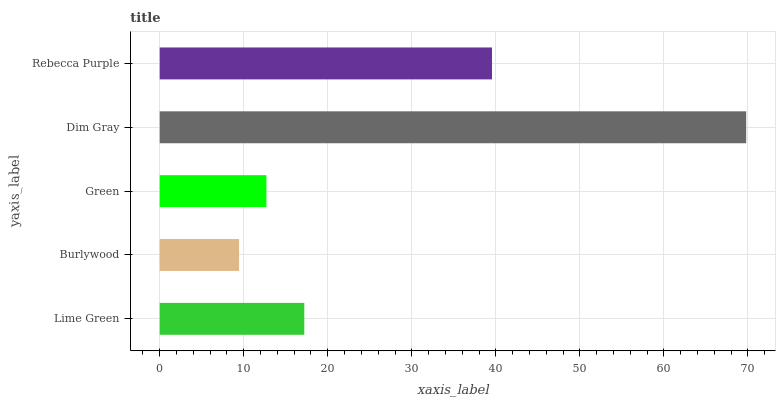Is Burlywood the minimum?
Answer yes or no. Yes. Is Dim Gray the maximum?
Answer yes or no. Yes. Is Green the minimum?
Answer yes or no. No. Is Green the maximum?
Answer yes or no. No. Is Green greater than Burlywood?
Answer yes or no. Yes. Is Burlywood less than Green?
Answer yes or no. Yes. Is Burlywood greater than Green?
Answer yes or no. No. Is Green less than Burlywood?
Answer yes or no. No. Is Lime Green the high median?
Answer yes or no. Yes. Is Lime Green the low median?
Answer yes or no. Yes. Is Dim Gray the high median?
Answer yes or no. No. Is Burlywood the low median?
Answer yes or no. No. 